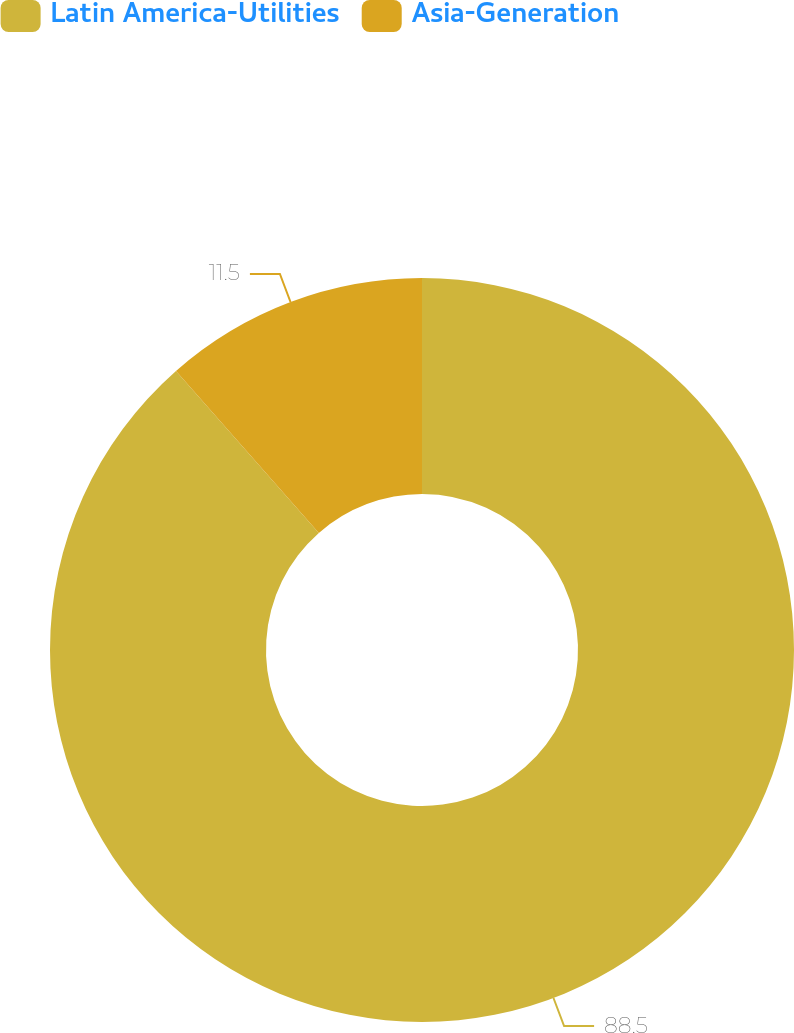Convert chart to OTSL. <chart><loc_0><loc_0><loc_500><loc_500><pie_chart><fcel>Latin America-Utilities<fcel>Asia-Generation<nl><fcel>88.5%<fcel>11.5%<nl></chart> 